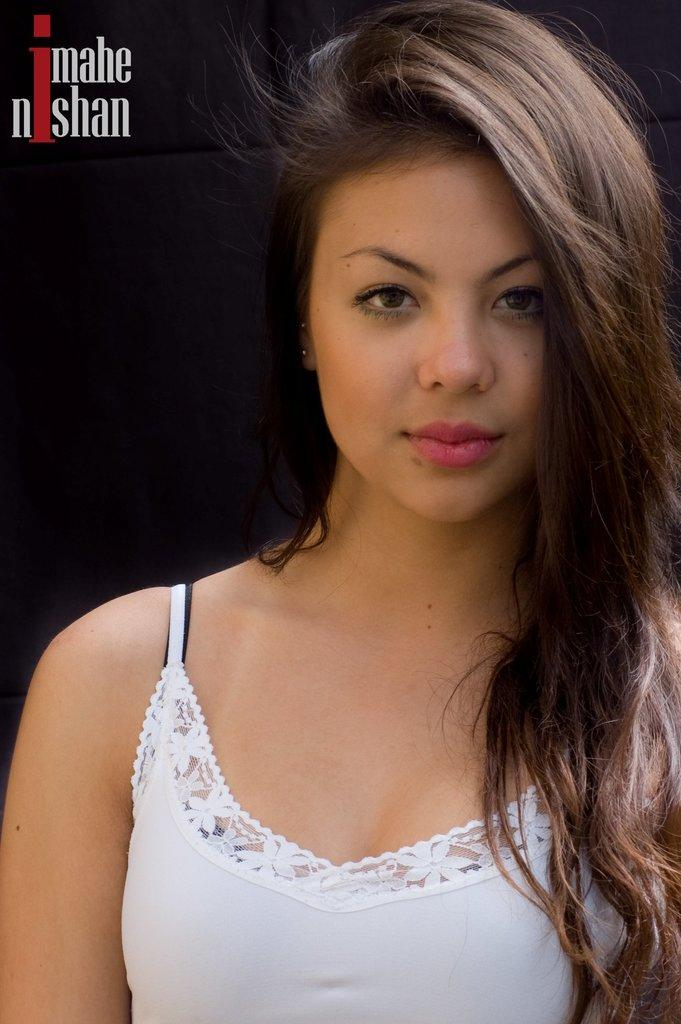Who is the main subject in the image? There is a lady in the image. the image. What is the lady doing in the image? The lady is posing for a picture. Is there any text visible in the image? Yes, there is some text in the top left corner of the image. How many crayons can be seen in the image? There are no crayons present in the image. What type of bear is standing next to the lady in the image? There is no bear present in the image. 